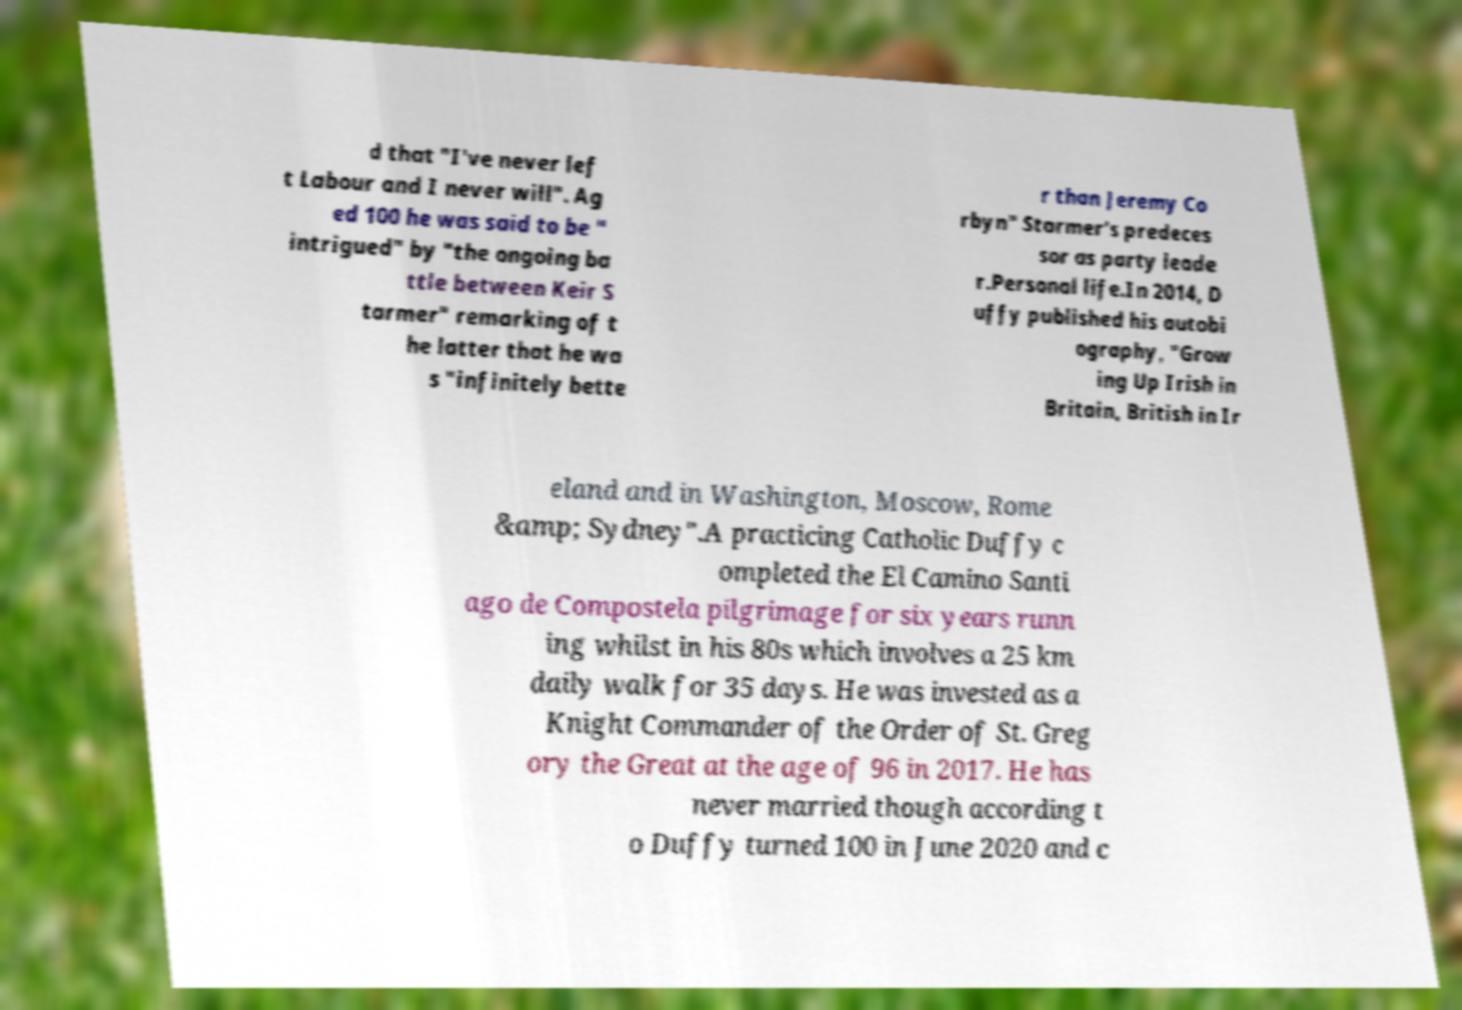Could you extract and type out the text from this image? d that "I've never lef t Labour and I never will". Ag ed 100 he was said to be " intrigued" by "the ongoing ba ttle between Keir S tarmer" remarking of t he latter that he wa s "infinitely bette r than Jeremy Co rbyn" Starmer's predeces sor as party leade r.Personal life.In 2014, D uffy published his autobi ography, "Grow ing Up Irish in Britain, British in Ir eland and in Washington, Moscow, Rome &amp; Sydney".A practicing Catholic Duffy c ompleted the El Camino Santi ago de Compostela pilgrimage for six years runn ing whilst in his 80s which involves a 25 km daily walk for 35 days. He was invested as a Knight Commander of the Order of St. Greg ory the Great at the age of 96 in 2017. He has never married though according t o Duffy turned 100 in June 2020 and c 